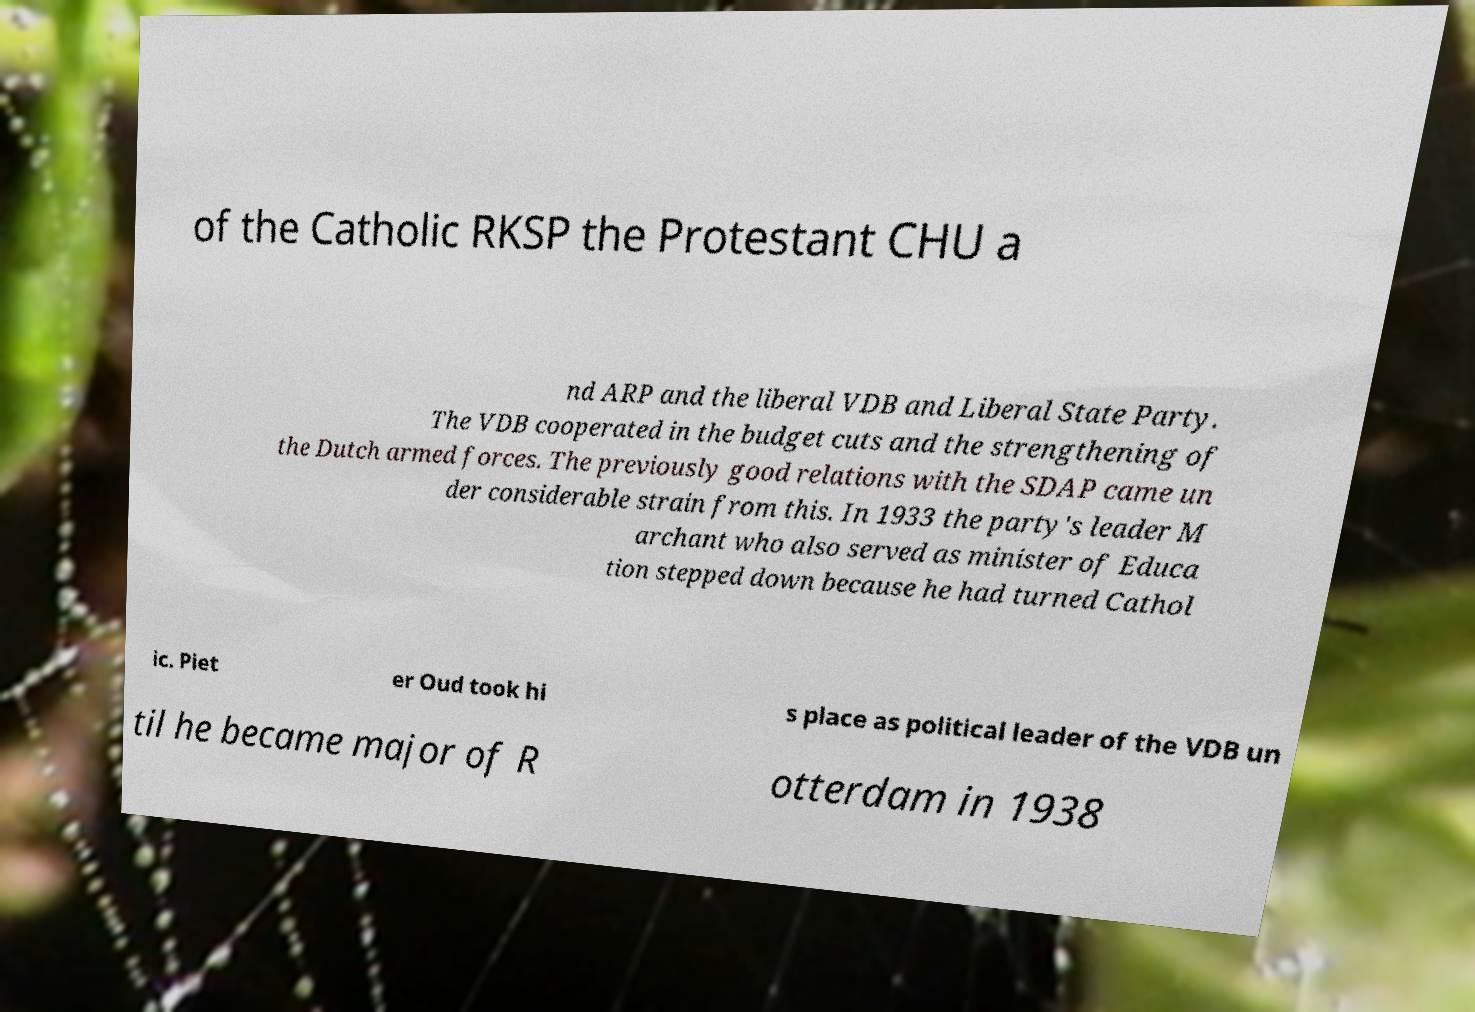Please read and relay the text visible in this image. What does it say? of the Catholic RKSP the Protestant CHU a nd ARP and the liberal VDB and Liberal State Party. The VDB cooperated in the budget cuts and the strengthening of the Dutch armed forces. The previously good relations with the SDAP came un der considerable strain from this. In 1933 the party's leader M archant who also served as minister of Educa tion stepped down because he had turned Cathol ic. Piet er Oud took hi s place as political leader of the VDB un til he became major of R otterdam in 1938 